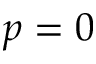Convert formula to latex. <formula><loc_0><loc_0><loc_500><loc_500>p = 0</formula> 